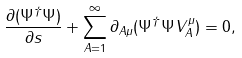Convert formula to latex. <formula><loc_0><loc_0><loc_500><loc_500>\frac { \partial ( \Psi ^ { \dagger } \Psi ) } { \partial s } + \sum _ { A = 1 } ^ { \infty } \partial _ { A \mu } ( \Psi ^ { \dagger } \Psi V ^ { \mu } _ { A } ) = 0 ,</formula> 